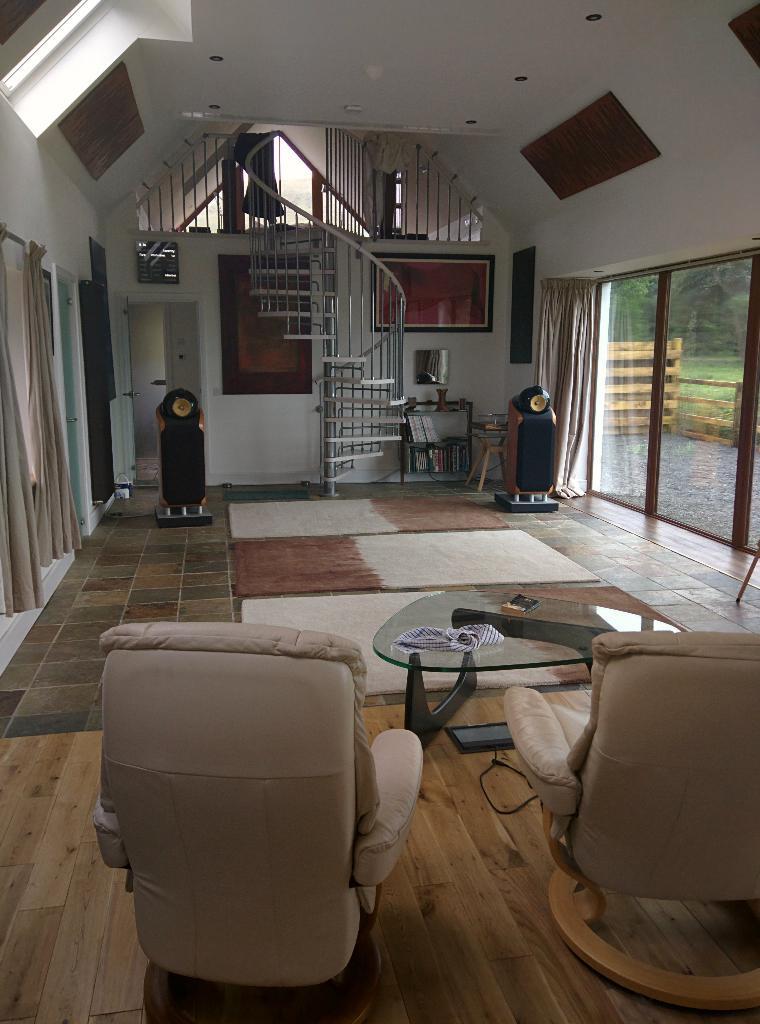Describe this image in one or two sentences. In this image we can see some chairs, table, doormat, floor mat on the right side of the image there is glass door and on left side of the image there are some curtains, tables and in the background of the image there are stairs and a wall. 